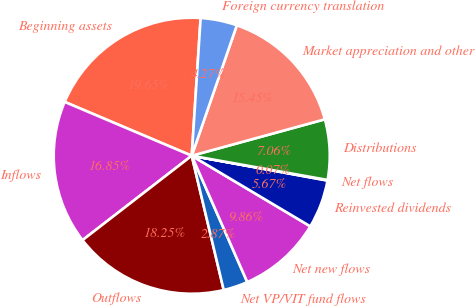<chart> <loc_0><loc_0><loc_500><loc_500><pie_chart><fcel>Beginning assets<fcel>Inflows<fcel>Outflows<fcel>Net VP/VIT fund flows<fcel>Net new flows<fcel>Reinvested dividends<fcel>Net flows<fcel>Distributions<fcel>Market appreciation and other<fcel>Foreign currency translation<nl><fcel>19.65%<fcel>16.85%<fcel>18.25%<fcel>2.87%<fcel>9.86%<fcel>5.67%<fcel>0.07%<fcel>7.06%<fcel>15.45%<fcel>4.27%<nl></chart> 